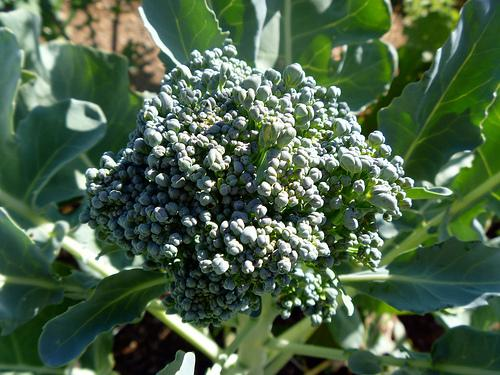Question: when is this taking place?
Choices:
A. Nighttime.
B. Sunset.
C. Sunrise.
D. Daylight.
Answer with the letter. Answer: D Question: what are the objects protruding from the plant at the base?
Choices:
A. Insects.
B. Fungi.
C. Leaves.
D. Thorns.
Answer with the letter. Answer: C Question: how many full plants are visible in the photo?
Choices:
A. One.
B. Two.
C. Four.
D. Six.
Answer with the letter. Answer: A 